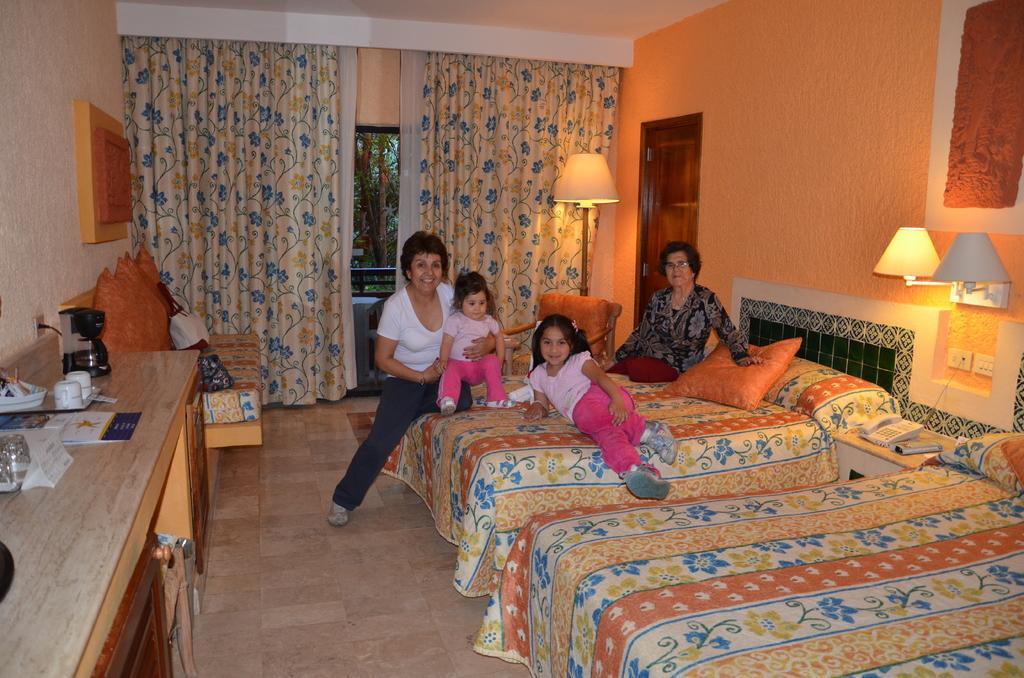How would you summarize this image in a sentence or two? This picture we can see the bed which is covered with colorful cloth two children sitting on the bed and two Women's are sitting on the bed beside there is a couch and pillows back side there is a cloth which is hang to the window this is a complete room. 